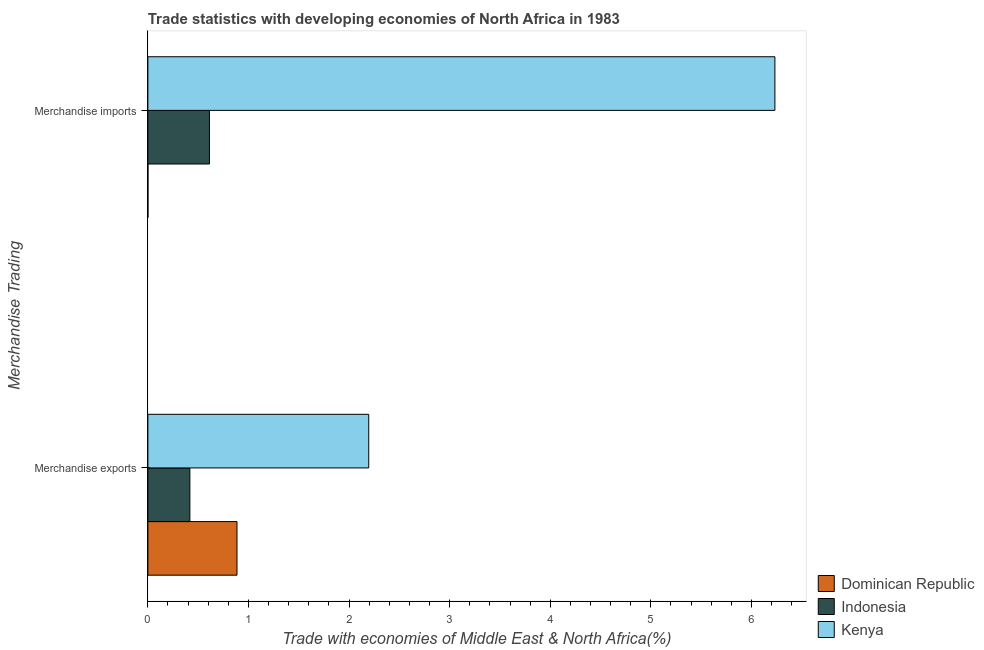How many different coloured bars are there?
Give a very brief answer. 3. How many bars are there on the 2nd tick from the bottom?
Ensure brevity in your answer.  3. What is the label of the 2nd group of bars from the top?
Your response must be concise. Merchandise exports. What is the merchandise imports in Dominican Republic?
Give a very brief answer. 0. Across all countries, what is the maximum merchandise imports?
Provide a succinct answer. 6.23. Across all countries, what is the minimum merchandise exports?
Your answer should be very brief. 0.42. In which country was the merchandise imports maximum?
Give a very brief answer. Kenya. In which country was the merchandise exports minimum?
Offer a very short reply. Indonesia. What is the total merchandise exports in the graph?
Provide a succinct answer. 3.5. What is the difference between the merchandise imports in Dominican Republic and that in Kenya?
Your answer should be compact. -6.23. What is the difference between the merchandise exports in Kenya and the merchandise imports in Indonesia?
Ensure brevity in your answer.  1.58. What is the average merchandise imports per country?
Your answer should be very brief. 2.28. What is the difference between the merchandise exports and merchandise imports in Dominican Republic?
Provide a succinct answer. 0.89. In how many countries, is the merchandise exports greater than 0.8 %?
Ensure brevity in your answer.  2. What is the ratio of the merchandise imports in Kenya to that in Dominican Republic?
Provide a succinct answer. 8760.89. Is the merchandise exports in Kenya less than that in Indonesia?
Make the answer very short. No. In how many countries, is the merchandise imports greater than the average merchandise imports taken over all countries?
Offer a terse response. 1. What does the 3rd bar from the top in Merchandise exports represents?
Your response must be concise. Dominican Republic. What does the 3rd bar from the bottom in Merchandise exports represents?
Your response must be concise. Kenya. How many bars are there?
Offer a very short reply. 6. Are all the bars in the graph horizontal?
Give a very brief answer. Yes. Are the values on the major ticks of X-axis written in scientific E-notation?
Give a very brief answer. No. What is the title of the graph?
Provide a succinct answer. Trade statistics with developing economies of North Africa in 1983. What is the label or title of the X-axis?
Keep it short and to the point. Trade with economies of Middle East & North Africa(%). What is the label or title of the Y-axis?
Offer a terse response. Merchandise Trading. What is the Trade with economies of Middle East & North Africa(%) of Dominican Republic in Merchandise exports?
Your answer should be compact. 0.89. What is the Trade with economies of Middle East & North Africa(%) in Indonesia in Merchandise exports?
Provide a succinct answer. 0.42. What is the Trade with economies of Middle East & North Africa(%) of Kenya in Merchandise exports?
Make the answer very short. 2.2. What is the Trade with economies of Middle East & North Africa(%) of Dominican Republic in Merchandise imports?
Give a very brief answer. 0. What is the Trade with economies of Middle East & North Africa(%) in Indonesia in Merchandise imports?
Offer a terse response. 0.61. What is the Trade with economies of Middle East & North Africa(%) in Kenya in Merchandise imports?
Give a very brief answer. 6.23. Across all Merchandise Trading, what is the maximum Trade with economies of Middle East & North Africa(%) of Dominican Republic?
Your response must be concise. 0.89. Across all Merchandise Trading, what is the maximum Trade with economies of Middle East & North Africa(%) of Indonesia?
Your answer should be very brief. 0.61. Across all Merchandise Trading, what is the maximum Trade with economies of Middle East & North Africa(%) of Kenya?
Make the answer very short. 6.23. Across all Merchandise Trading, what is the minimum Trade with economies of Middle East & North Africa(%) of Dominican Republic?
Offer a terse response. 0. Across all Merchandise Trading, what is the minimum Trade with economies of Middle East & North Africa(%) of Indonesia?
Provide a succinct answer. 0.42. Across all Merchandise Trading, what is the minimum Trade with economies of Middle East & North Africa(%) of Kenya?
Offer a very short reply. 2.2. What is the total Trade with economies of Middle East & North Africa(%) of Dominican Republic in the graph?
Your answer should be very brief. 0.89. What is the total Trade with economies of Middle East & North Africa(%) of Indonesia in the graph?
Provide a short and direct response. 1.03. What is the total Trade with economies of Middle East & North Africa(%) in Kenya in the graph?
Offer a terse response. 8.43. What is the difference between the Trade with economies of Middle East & North Africa(%) in Dominican Republic in Merchandise exports and that in Merchandise imports?
Make the answer very short. 0.89. What is the difference between the Trade with economies of Middle East & North Africa(%) of Indonesia in Merchandise exports and that in Merchandise imports?
Give a very brief answer. -0.19. What is the difference between the Trade with economies of Middle East & North Africa(%) in Kenya in Merchandise exports and that in Merchandise imports?
Ensure brevity in your answer.  -4.04. What is the difference between the Trade with economies of Middle East & North Africa(%) of Dominican Republic in Merchandise exports and the Trade with economies of Middle East & North Africa(%) of Indonesia in Merchandise imports?
Provide a short and direct response. 0.27. What is the difference between the Trade with economies of Middle East & North Africa(%) of Dominican Republic in Merchandise exports and the Trade with economies of Middle East & North Africa(%) of Kenya in Merchandise imports?
Your response must be concise. -5.35. What is the difference between the Trade with economies of Middle East & North Africa(%) in Indonesia in Merchandise exports and the Trade with economies of Middle East & North Africa(%) in Kenya in Merchandise imports?
Provide a short and direct response. -5.82. What is the average Trade with economies of Middle East & North Africa(%) in Dominican Republic per Merchandise Trading?
Give a very brief answer. 0.44. What is the average Trade with economies of Middle East & North Africa(%) in Indonesia per Merchandise Trading?
Your answer should be compact. 0.51. What is the average Trade with economies of Middle East & North Africa(%) of Kenya per Merchandise Trading?
Give a very brief answer. 4.21. What is the difference between the Trade with economies of Middle East & North Africa(%) in Dominican Republic and Trade with economies of Middle East & North Africa(%) in Indonesia in Merchandise exports?
Make the answer very short. 0.47. What is the difference between the Trade with economies of Middle East & North Africa(%) of Dominican Republic and Trade with economies of Middle East & North Africa(%) of Kenya in Merchandise exports?
Provide a short and direct response. -1.31. What is the difference between the Trade with economies of Middle East & North Africa(%) of Indonesia and Trade with economies of Middle East & North Africa(%) of Kenya in Merchandise exports?
Offer a terse response. -1.78. What is the difference between the Trade with economies of Middle East & North Africa(%) of Dominican Republic and Trade with economies of Middle East & North Africa(%) of Indonesia in Merchandise imports?
Your answer should be very brief. -0.61. What is the difference between the Trade with economies of Middle East & North Africa(%) in Dominican Republic and Trade with economies of Middle East & North Africa(%) in Kenya in Merchandise imports?
Offer a terse response. -6.23. What is the difference between the Trade with economies of Middle East & North Africa(%) of Indonesia and Trade with economies of Middle East & North Africa(%) of Kenya in Merchandise imports?
Ensure brevity in your answer.  -5.62. What is the ratio of the Trade with economies of Middle East & North Africa(%) of Dominican Republic in Merchandise exports to that in Merchandise imports?
Provide a short and direct response. 1245.22. What is the ratio of the Trade with economies of Middle East & North Africa(%) of Indonesia in Merchandise exports to that in Merchandise imports?
Keep it short and to the point. 0.68. What is the ratio of the Trade with economies of Middle East & North Africa(%) of Kenya in Merchandise exports to that in Merchandise imports?
Your response must be concise. 0.35. What is the difference between the highest and the second highest Trade with economies of Middle East & North Africa(%) in Dominican Republic?
Ensure brevity in your answer.  0.89. What is the difference between the highest and the second highest Trade with economies of Middle East & North Africa(%) of Indonesia?
Keep it short and to the point. 0.19. What is the difference between the highest and the second highest Trade with economies of Middle East & North Africa(%) of Kenya?
Your answer should be compact. 4.04. What is the difference between the highest and the lowest Trade with economies of Middle East & North Africa(%) of Dominican Republic?
Your response must be concise. 0.89. What is the difference between the highest and the lowest Trade with economies of Middle East & North Africa(%) of Indonesia?
Your response must be concise. 0.19. What is the difference between the highest and the lowest Trade with economies of Middle East & North Africa(%) in Kenya?
Make the answer very short. 4.04. 